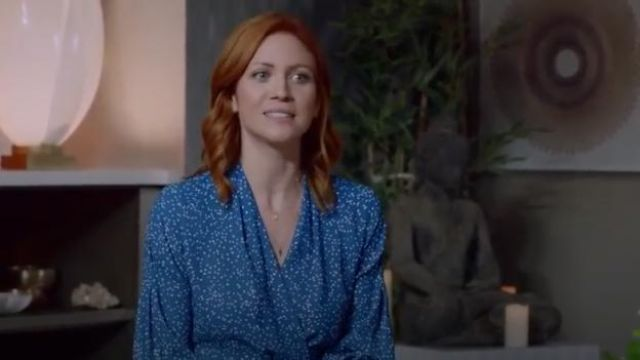What is this photo about? This image features a woman with red hair sitting on a gray couch in a living room setting. She is wearing a blue dress with white polka dots, suggesting a casual, yet stylish attire. Her expression is pleasant, gazing slightly off-camera which, along with the calm decoration of the room including a white lamp and a plant, creates a serene atmosphere. 